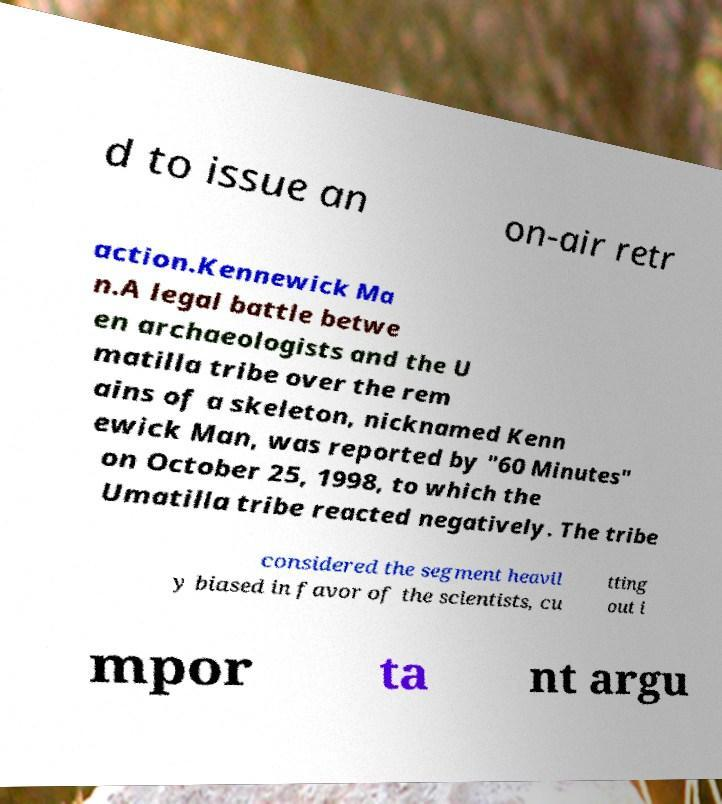Can you accurately transcribe the text from the provided image for me? d to issue an on-air retr action.Kennewick Ma n.A legal battle betwe en archaeologists and the U matilla tribe over the rem ains of a skeleton, nicknamed Kenn ewick Man, was reported by "60 Minutes" on October 25, 1998, to which the Umatilla tribe reacted negatively. The tribe considered the segment heavil y biased in favor of the scientists, cu tting out i mpor ta nt argu 